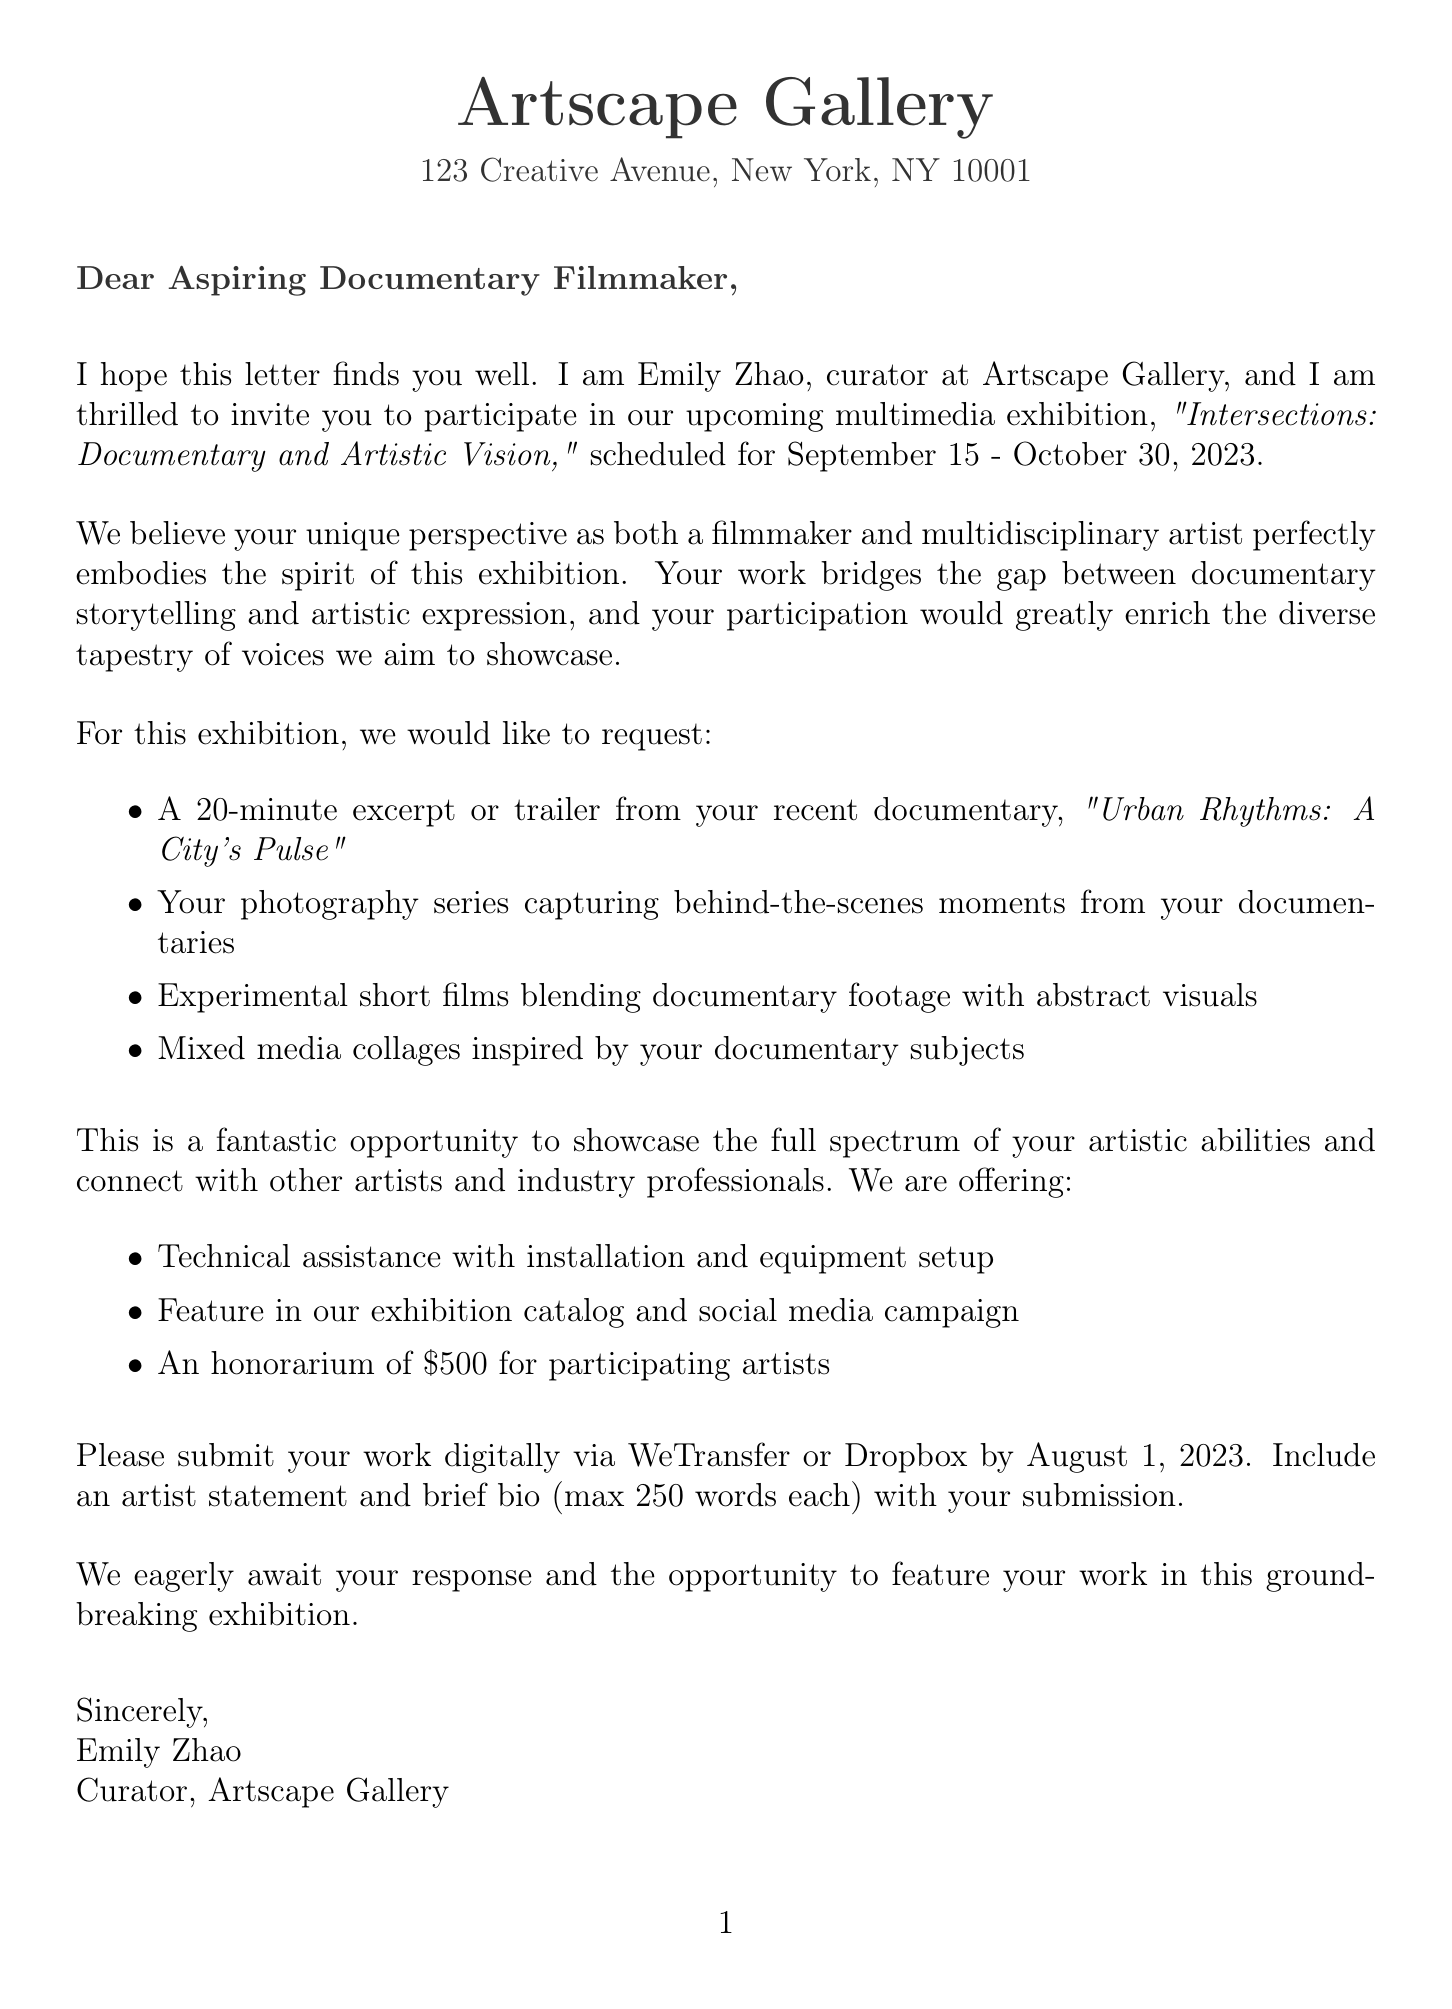what is the name of the gallery? The gallery name is mentioned at the beginning of the letter.
Answer: Artscape Gallery who is the curator of the exhibition? The curator’s name is included in the introduction of the letter.
Answer: Emily Zhao what is the exhibition title? The title of the exhibition is explicitly stated in the letter.
Answer: Intersections: Documentary and Artistic Vision what are the exhibition dates? The exhibition dates are clearly provided in the exhibition details section.
Answer: September 15 - October 30, 2023 what is the submission deadline? The deadline for submissions is specified in the submission guidelines section of the letter.
Answer: August 1, 2023 what type of work is requested from the filmmaker? The request for specific work types is listed in an itemized format in the letter.
Answer: A 20-minute excerpt or trailer what financial support is offered to artists? The financial support detail is mentioned among other support offered.
Answer: Honorarium of $500 what is one networking opportunity mentioned in the letter? The letter states potential connections that could be made at the exhibition.
Answer: Connect with other artists what is the theme of the exhibition? The theme is clearly outlined in the exhibition details section.
Answer: The convergence of documentary filmmaking and other artistic mediums what form of media is suggested to be included besides the documentary? The letter outlines various artistic forms to be included.
Answer: Mixed media collages 